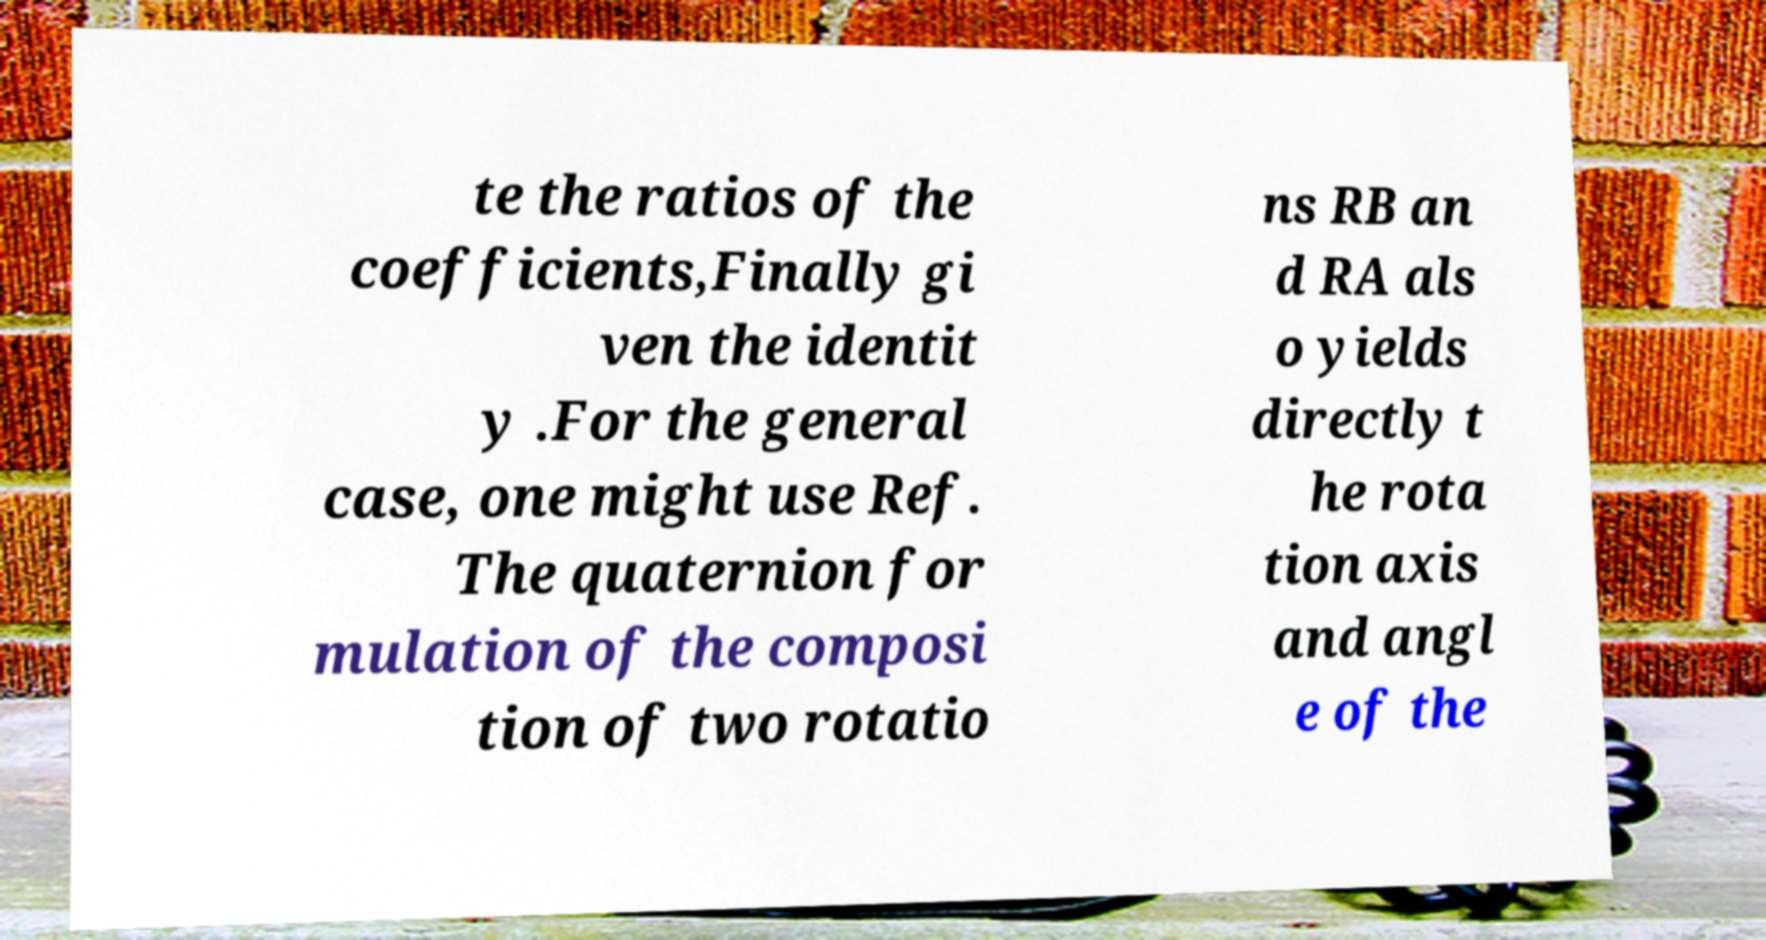Can you read and provide the text displayed in the image?This photo seems to have some interesting text. Can you extract and type it out for me? te the ratios of the coefficients,Finally gi ven the identit y .For the general case, one might use Ref. The quaternion for mulation of the composi tion of two rotatio ns RB an d RA als o yields directly t he rota tion axis and angl e of the 